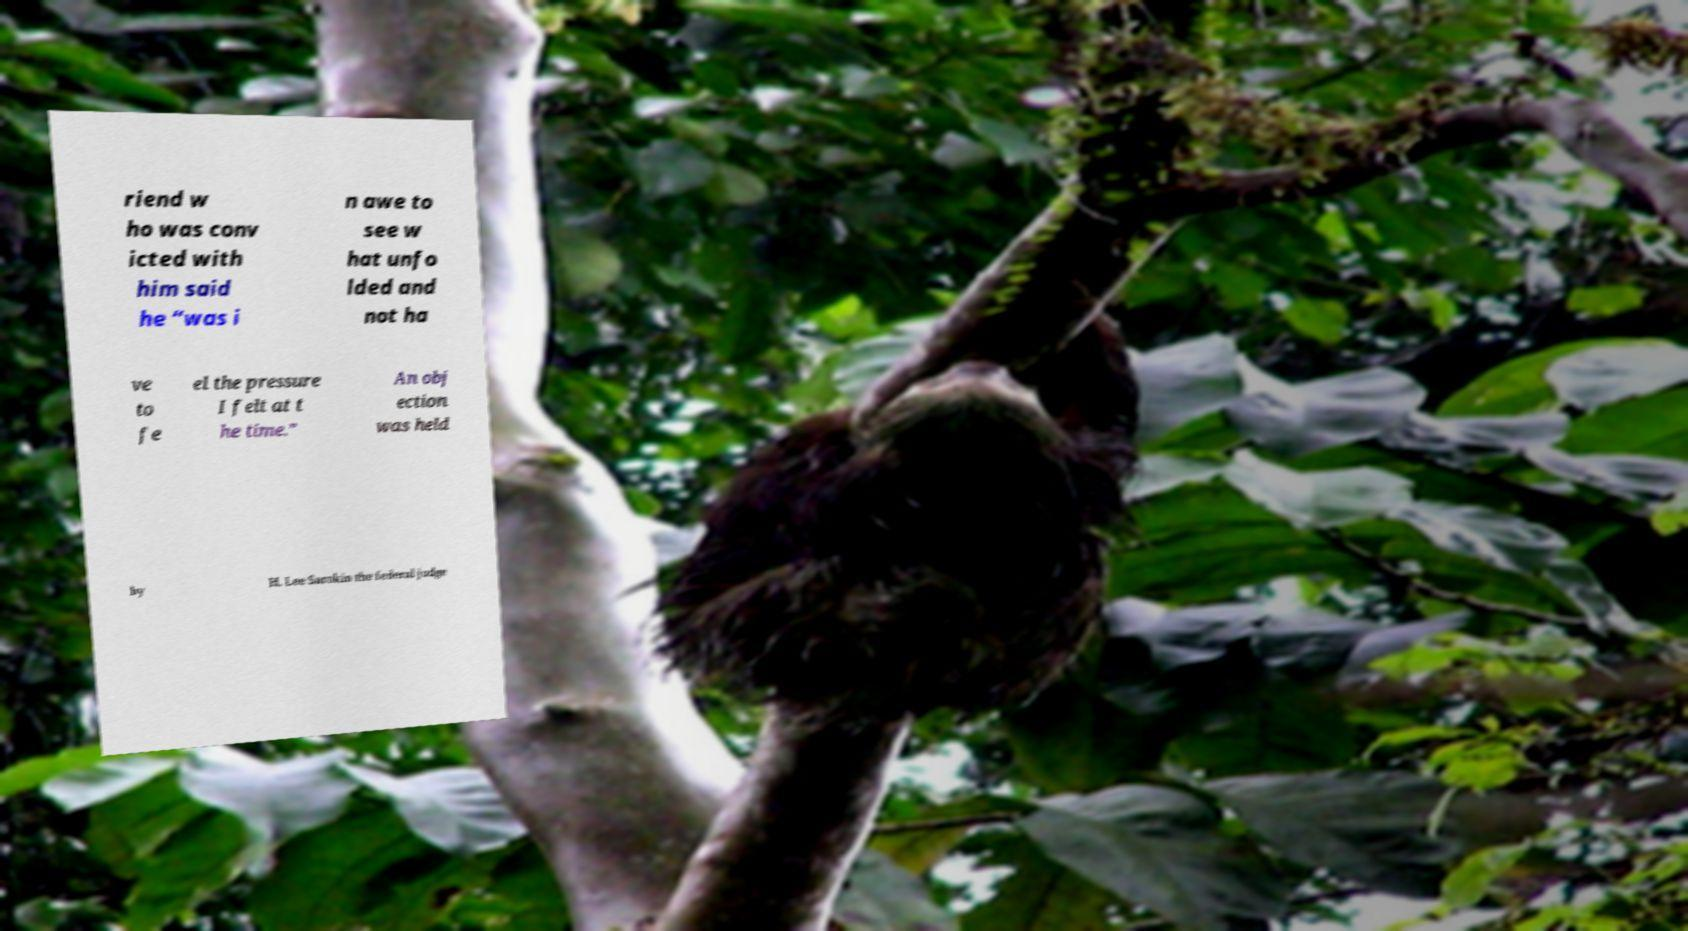Can you read and provide the text displayed in the image?This photo seems to have some interesting text. Can you extract and type it out for me? riend w ho was conv icted with him said he “was i n awe to see w hat unfo lded and not ha ve to fe el the pressure I felt at t he time.” An obj ection was held by H. Lee Sarokin the federal judge 